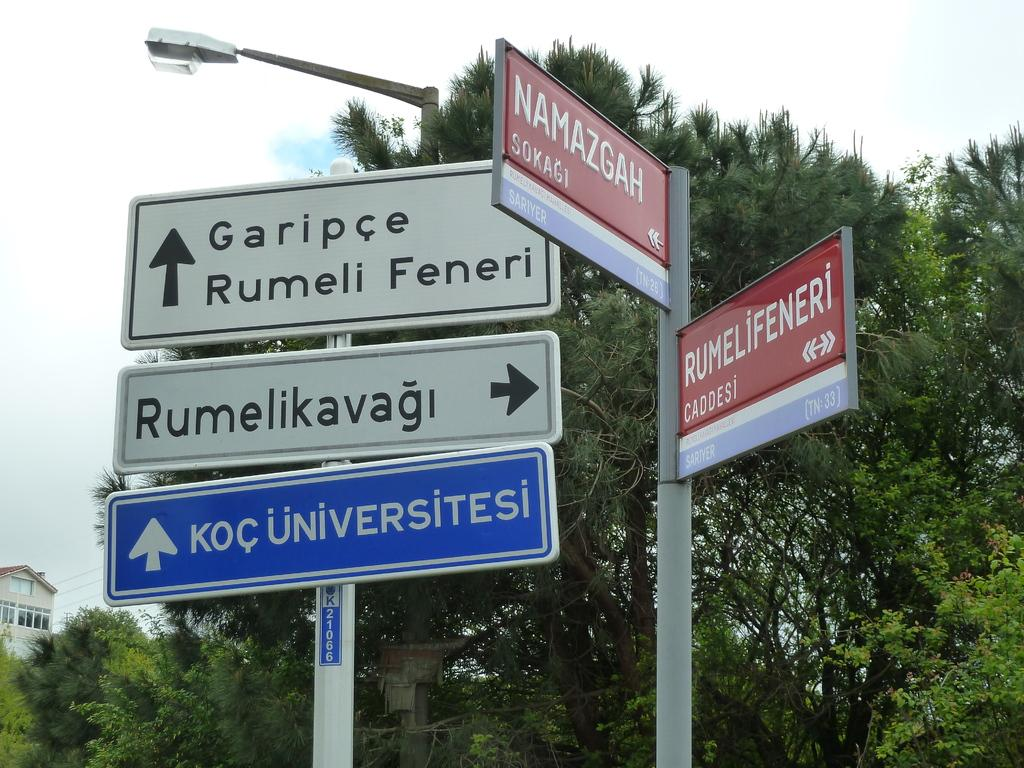<image>
Create a compact narrative representing the image presented. Directional signs have Garipce Rumell Fenerl straight ahead and Rumelikavag to the right. 